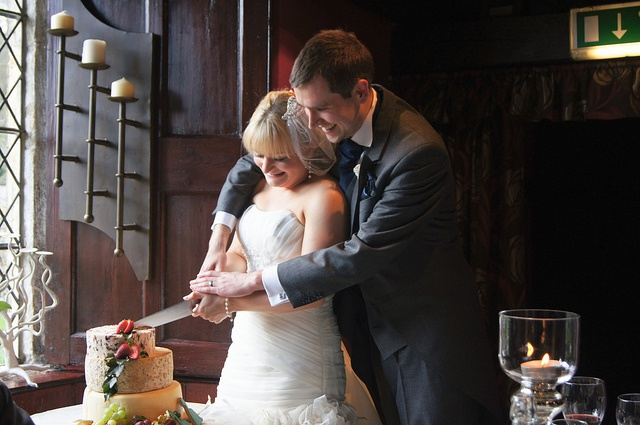Describe the objects in this image and their specific colors. I can see people in white, black, maroon, gray, and lightgray tones, people in white, darkgray, and gray tones, cake in white, gray, brown, and maroon tones, wine glass in white, black, gray, and darkgray tones, and wine glass in white, black, gray, maroon, and brown tones in this image. 